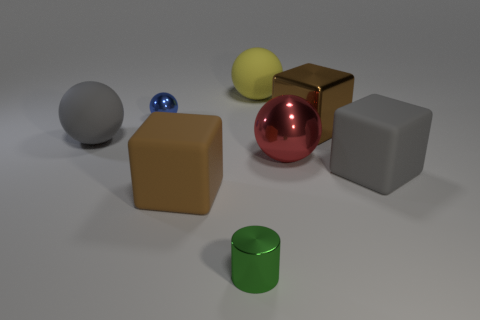Add 2 big brown matte balls. How many objects exist? 10 Subtract all cylinders. How many objects are left? 7 Subtract 1 green cylinders. How many objects are left? 7 Subtract all tiny brown blocks. Subtract all tiny blue spheres. How many objects are left? 7 Add 8 gray spheres. How many gray spheres are left? 9 Add 1 tiny cyan shiny balls. How many tiny cyan shiny balls exist? 1 